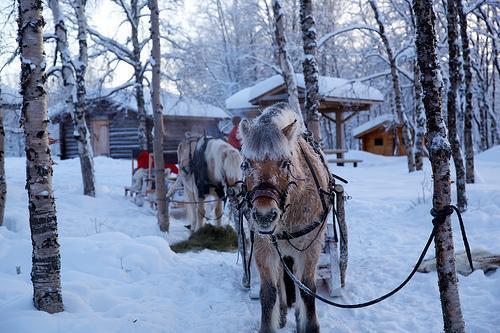How many houses are in the background?
Give a very brief answer. 2. How many horses are in the photo?
Give a very brief answer. 2. 